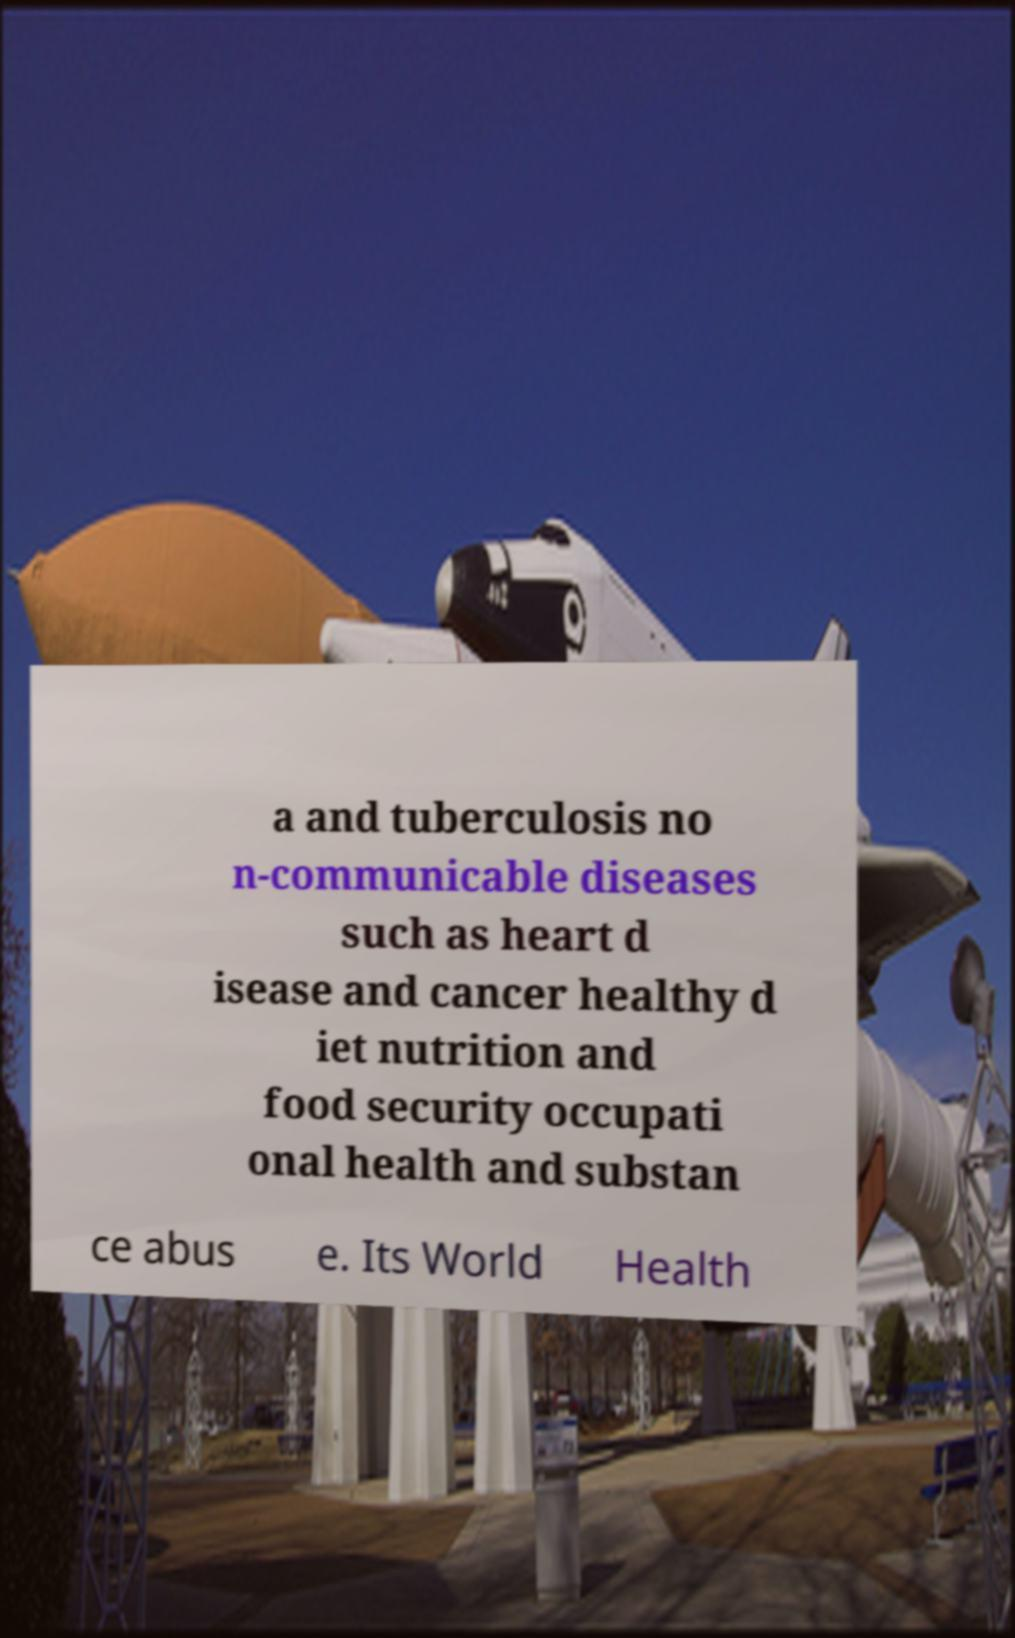There's text embedded in this image that I need extracted. Can you transcribe it verbatim? a and tuberculosis no n-communicable diseases such as heart d isease and cancer healthy d iet nutrition and food security occupati onal health and substan ce abus e. Its World Health 